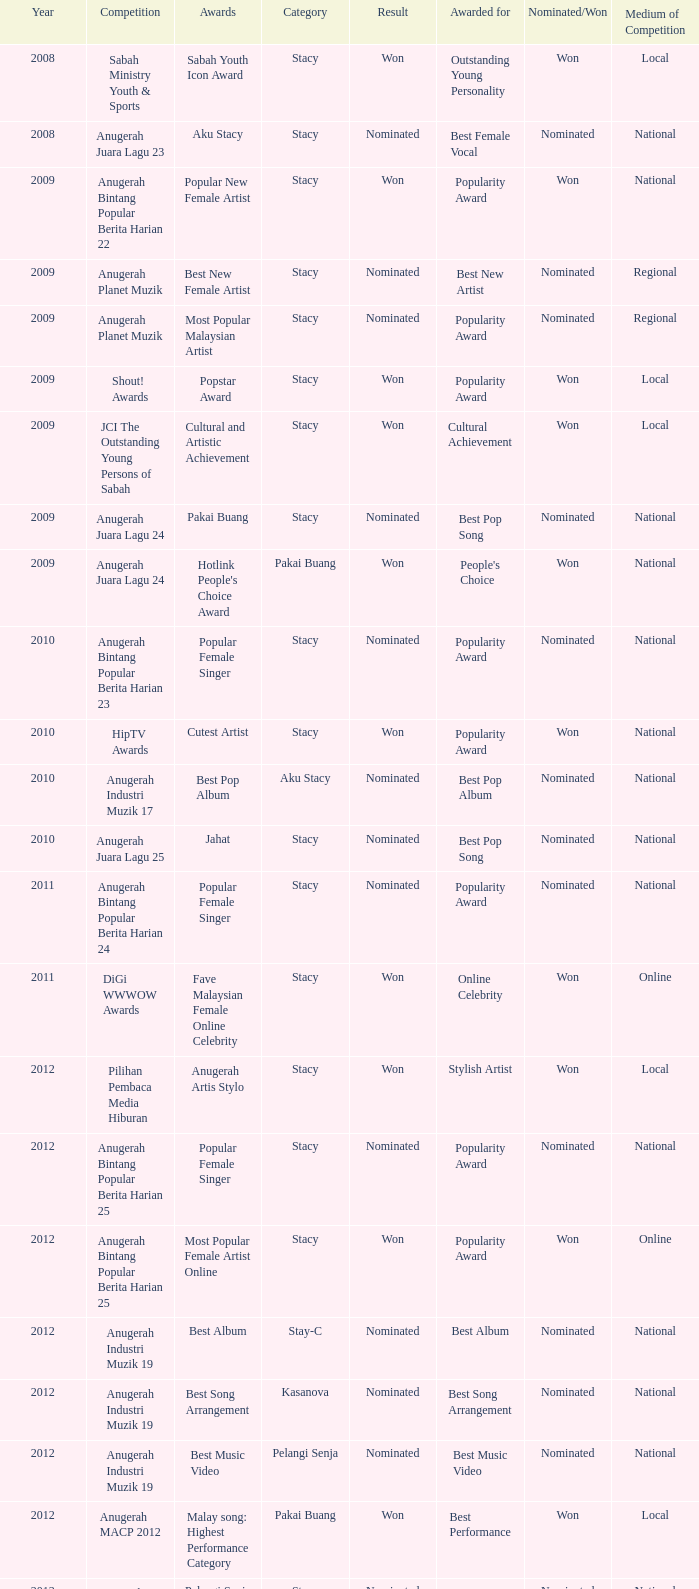What year has Stacy as the category and award of Best Reality Star in Social Media? 2013.0. 